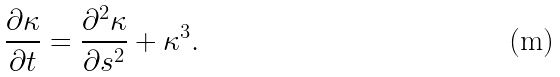<formula> <loc_0><loc_0><loc_500><loc_500>\frac { \partial \kappa } { \partial t } = \frac { \partial ^ { 2 } \kappa } { \partial s ^ { 2 } } + \kappa ^ { 3 } .</formula> 